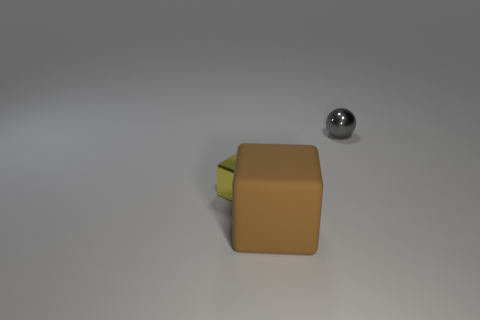Is there any other thing that is the same size as the matte block?
Offer a terse response. No. The yellow object is what size?
Make the answer very short. Small. What number of large rubber things are behind the small gray shiny sphere?
Give a very brief answer. 0. Is the material of the cube behind the matte block the same as the block in front of the yellow shiny block?
Your answer should be compact. No. There is a tiny object to the right of the tiny shiny object on the left side of the small thing behind the shiny block; what is its shape?
Make the answer very short. Sphere. What shape is the brown matte object?
Offer a terse response. Cube. There is a thing that is the same size as the metal ball; what is its shape?
Keep it short and to the point. Cube. How many other objects are there of the same color as the big cube?
Your response must be concise. 0. There is a thing in front of the tiny yellow metallic cube; does it have the same shape as the shiny object that is on the left side of the brown matte object?
Offer a terse response. Yes. What number of objects are objects right of the matte object or cubes that are left of the big thing?
Your answer should be compact. 2. 